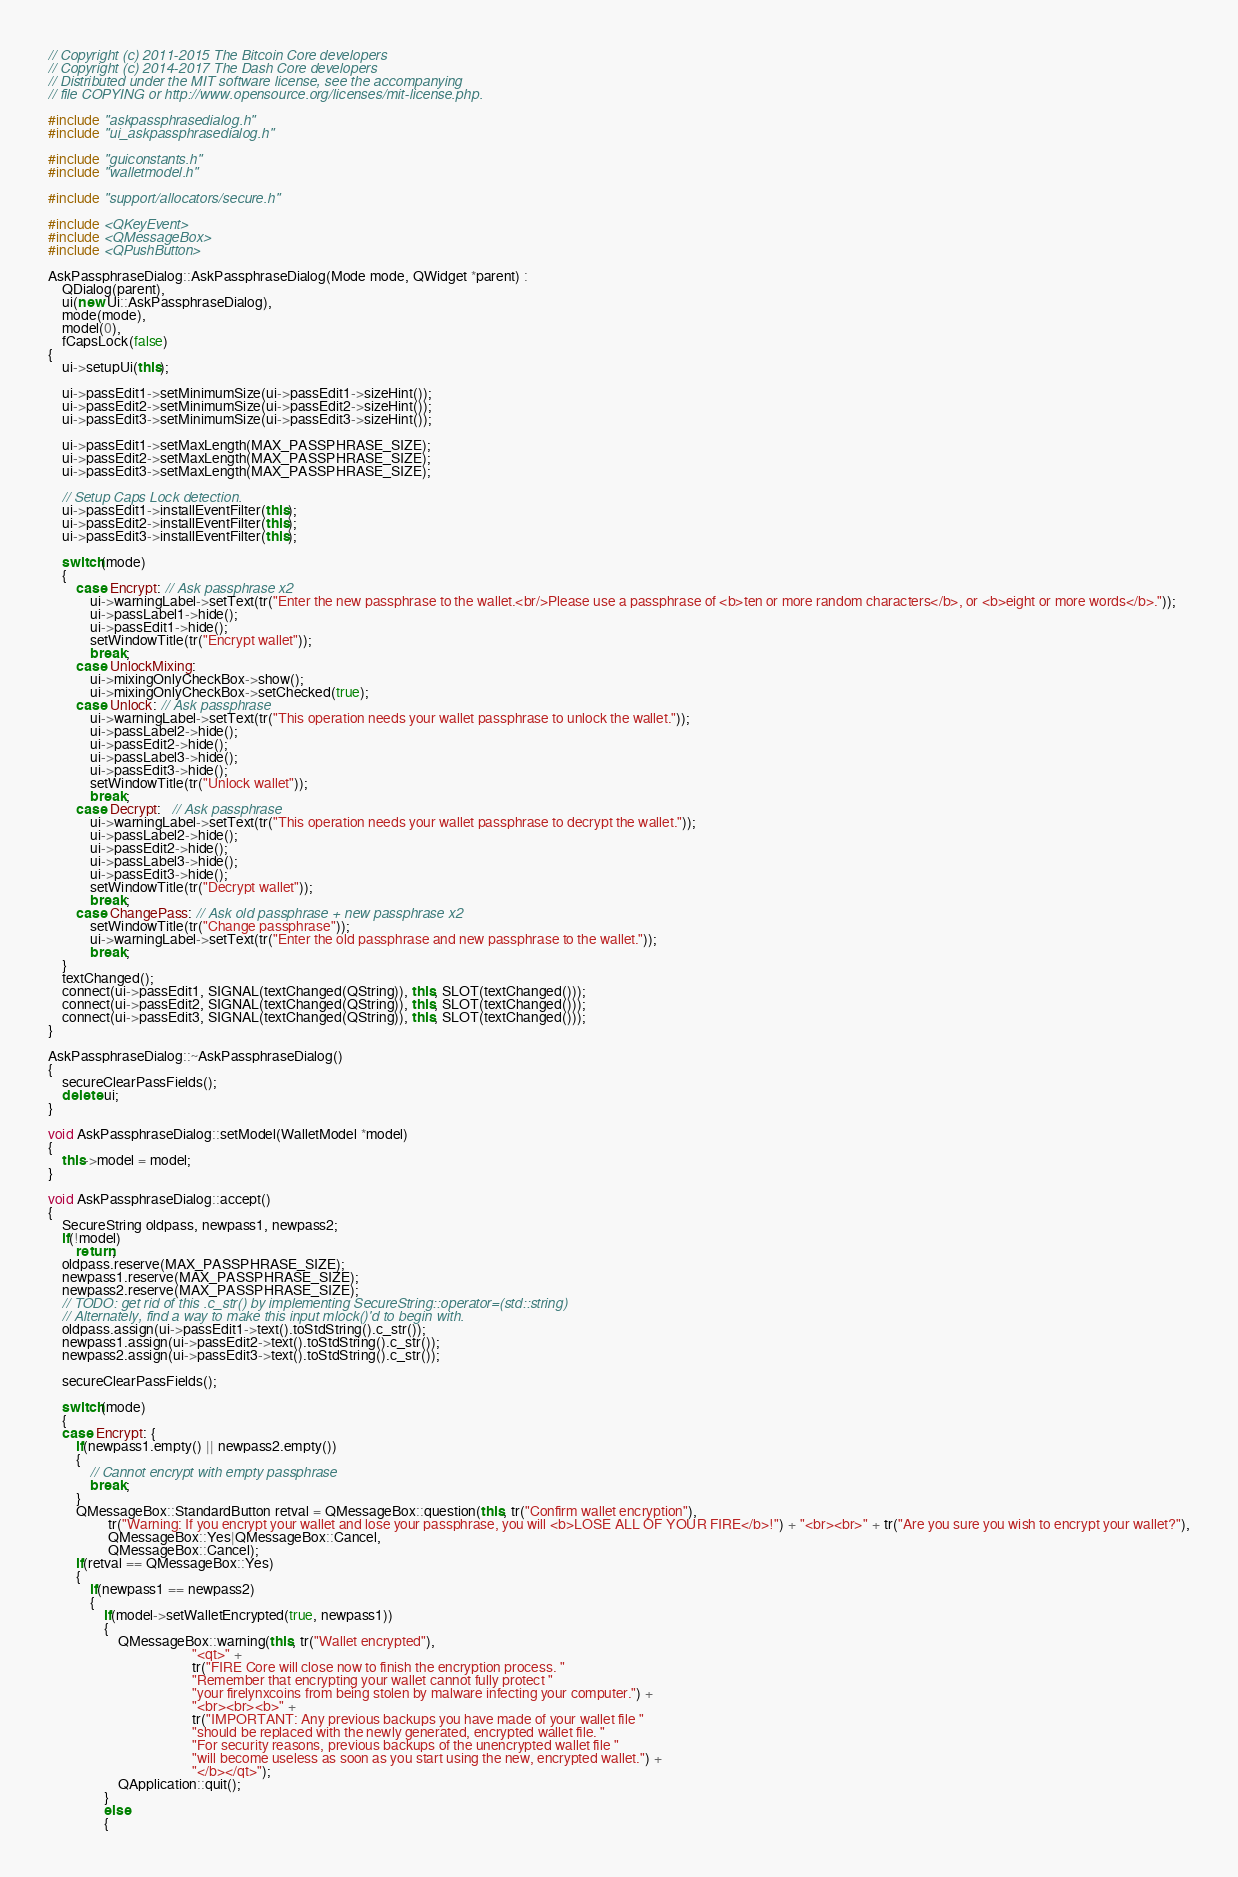Convert code to text. <code><loc_0><loc_0><loc_500><loc_500><_C++_>// Copyright (c) 2011-2015 The Bitcoin Core developers
// Copyright (c) 2014-2017 The Dash Core developers
// Distributed under the MIT software license, see the accompanying
// file COPYING or http://www.opensource.org/licenses/mit-license.php.

#include "askpassphrasedialog.h"
#include "ui_askpassphrasedialog.h"

#include "guiconstants.h"
#include "walletmodel.h"

#include "support/allocators/secure.h"

#include <QKeyEvent>
#include <QMessageBox>
#include <QPushButton>

AskPassphraseDialog::AskPassphraseDialog(Mode mode, QWidget *parent) :
    QDialog(parent),
    ui(new Ui::AskPassphraseDialog),
    mode(mode),
    model(0),
    fCapsLock(false)
{
    ui->setupUi(this);

    ui->passEdit1->setMinimumSize(ui->passEdit1->sizeHint());
    ui->passEdit2->setMinimumSize(ui->passEdit2->sizeHint());
    ui->passEdit3->setMinimumSize(ui->passEdit3->sizeHint());

    ui->passEdit1->setMaxLength(MAX_PASSPHRASE_SIZE);
    ui->passEdit2->setMaxLength(MAX_PASSPHRASE_SIZE);
    ui->passEdit3->setMaxLength(MAX_PASSPHRASE_SIZE);

    // Setup Caps Lock detection.
    ui->passEdit1->installEventFilter(this);
    ui->passEdit2->installEventFilter(this);
    ui->passEdit3->installEventFilter(this);

    switch(mode)
    {
        case Encrypt: // Ask passphrase x2
            ui->warningLabel->setText(tr("Enter the new passphrase to the wallet.<br/>Please use a passphrase of <b>ten or more random characters</b>, or <b>eight or more words</b>."));
            ui->passLabel1->hide();
            ui->passEdit1->hide();
            setWindowTitle(tr("Encrypt wallet"));
            break;
        case UnlockMixing:
            ui->mixingOnlyCheckBox->show();
            ui->mixingOnlyCheckBox->setChecked(true);
        case Unlock: // Ask passphrase
            ui->warningLabel->setText(tr("This operation needs your wallet passphrase to unlock the wallet."));
            ui->passLabel2->hide();
            ui->passEdit2->hide();
            ui->passLabel3->hide();
            ui->passEdit3->hide();
            setWindowTitle(tr("Unlock wallet"));
            break;
        case Decrypt:   // Ask passphrase
            ui->warningLabel->setText(tr("This operation needs your wallet passphrase to decrypt the wallet."));
            ui->passLabel2->hide();
            ui->passEdit2->hide();
            ui->passLabel3->hide();
            ui->passEdit3->hide();
            setWindowTitle(tr("Decrypt wallet"));
            break;
        case ChangePass: // Ask old passphrase + new passphrase x2
            setWindowTitle(tr("Change passphrase"));
            ui->warningLabel->setText(tr("Enter the old passphrase and new passphrase to the wallet."));
            break;
    }
    textChanged();
    connect(ui->passEdit1, SIGNAL(textChanged(QString)), this, SLOT(textChanged()));
    connect(ui->passEdit2, SIGNAL(textChanged(QString)), this, SLOT(textChanged()));
    connect(ui->passEdit3, SIGNAL(textChanged(QString)), this, SLOT(textChanged()));
}

AskPassphraseDialog::~AskPassphraseDialog()
{
    secureClearPassFields();
    delete ui;
}

void AskPassphraseDialog::setModel(WalletModel *model)
{
    this->model = model;
}

void AskPassphraseDialog::accept()
{
    SecureString oldpass, newpass1, newpass2;
    if(!model)
        return;
    oldpass.reserve(MAX_PASSPHRASE_SIZE);
    newpass1.reserve(MAX_PASSPHRASE_SIZE);
    newpass2.reserve(MAX_PASSPHRASE_SIZE);
    // TODO: get rid of this .c_str() by implementing SecureString::operator=(std::string)
    // Alternately, find a way to make this input mlock()'d to begin with.
    oldpass.assign(ui->passEdit1->text().toStdString().c_str());
    newpass1.assign(ui->passEdit2->text().toStdString().c_str());
    newpass2.assign(ui->passEdit3->text().toStdString().c_str());

    secureClearPassFields();

    switch(mode)
    {
    case Encrypt: {
        if(newpass1.empty() || newpass2.empty())
        {
            // Cannot encrypt with empty passphrase
            break;
        }
        QMessageBox::StandardButton retval = QMessageBox::question(this, tr("Confirm wallet encryption"),
                 tr("Warning: If you encrypt your wallet and lose your passphrase, you will <b>LOSE ALL OF YOUR FIRE</b>!") + "<br><br>" + tr("Are you sure you wish to encrypt your wallet?"),
                 QMessageBox::Yes|QMessageBox::Cancel,
                 QMessageBox::Cancel);
        if(retval == QMessageBox::Yes)
        {
            if(newpass1 == newpass2)
            {
                if(model->setWalletEncrypted(true, newpass1))
                {
                    QMessageBox::warning(this, tr("Wallet encrypted"),
                                         "<qt>" +
                                         tr("FIRE Core will close now to finish the encryption process. "
                                         "Remember that encrypting your wallet cannot fully protect "
                                         "your firelynxcoins from being stolen by malware infecting your computer.") +
                                         "<br><br><b>" +
                                         tr("IMPORTANT: Any previous backups you have made of your wallet file "
                                         "should be replaced with the newly generated, encrypted wallet file. "
                                         "For security reasons, previous backups of the unencrypted wallet file "
                                         "will become useless as soon as you start using the new, encrypted wallet.") +
                                         "</b></qt>");
                    QApplication::quit();
                }
                else
                {</code> 